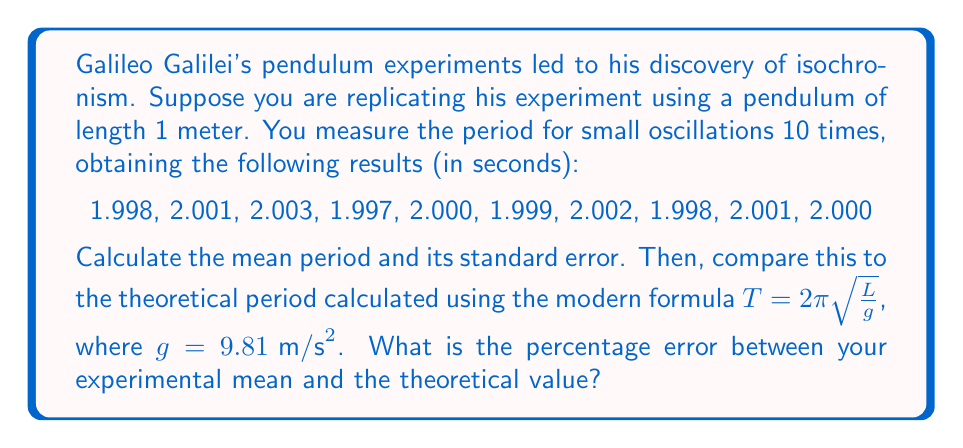Show me your answer to this math problem. To solve this problem, we'll follow these steps:

1. Calculate the mean period from the experimental data:
   $$\bar{T} = \frac{1}{n}\sum_{i=1}^n T_i = \frac{1}{10}(1.998 + 2.001 + ... + 2.000) = 1.9999 \text{ s}$$

2. Calculate the standard error of the mean:
   First, we need the standard deviation:
   $$s = \sqrt{\frac{1}{n-1}\sum_{i=1}^n (T_i - \bar{T})^2} = 0.002003 \text{ s}$$
   Then, the standard error:
   $$SE = \frac{s}{\sqrt{n}} = \frac{0.002003}{\sqrt{10}} = 0.000633 \text{ s}$$

3. Calculate the theoretical period:
   $$T_{theo} = 2\pi\sqrt{\frac{L}{g}} = 2\pi\sqrt{\frac{1}{9.81}} = 2.0064 \text{ s}$$

4. Calculate the percentage error:
   $$\text{Percentage Error} = \frac{|T_{theo} - \bar{T}|}{T_{theo}} \times 100\%$$
   $$= \frac{|2.0064 - 1.9999|}{2.0064} \times 100\% = 0.324\%$$
Answer: Mean period: $1.9999 \pm 0.000633$ s; Percentage error: 0.324% 